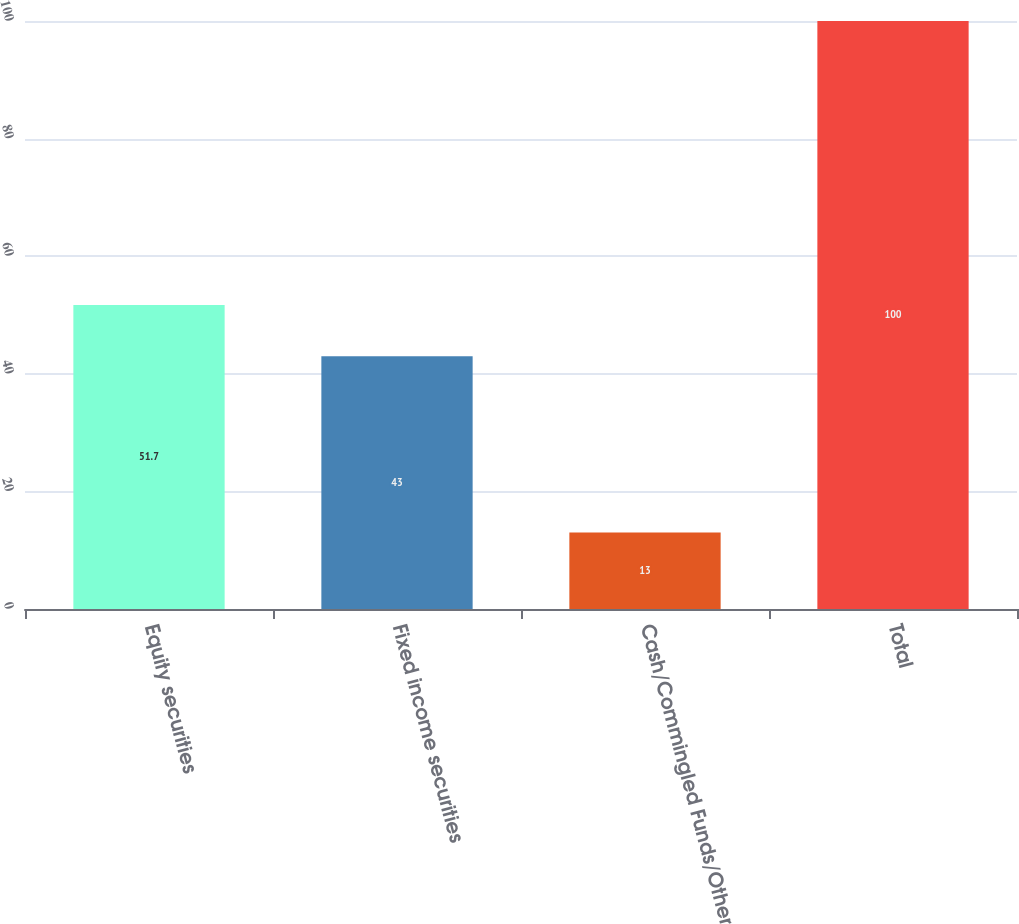<chart> <loc_0><loc_0><loc_500><loc_500><bar_chart><fcel>Equity securities<fcel>Fixed income securities<fcel>Cash/Commingled Funds/Other<fcel>Total<nl><fcel>51.7<fcel>43<fcel>13<fcel>100<nl></chart> 